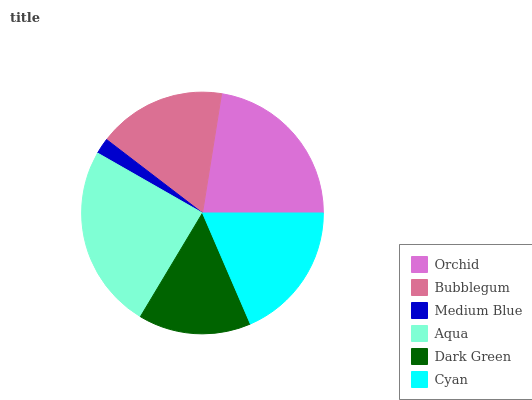Is Medium Blue the minimum?
Answer yes or no. Yes. Is Aqua the maximum?
Answer yes or no. Yes. Is Bubblegum the minimum?
Answer yes or no. No. Is Bubblegum the maximum?
Answer yes or no. No. Is Orchid greater than Bubblegum?
Answer yes or no. Yes. Is Bubblegum less than Orchid?
Answer yes or no. Yes. Is Bubblegum greater than Orchid?
Answer yes or no. No. Is Orchid less than Bubblegum?
Answer yes or no. No. Is Cyan the high median?
Answer yes or no. Yes. Is Bubblegum the low median?
Answer yes or no. Yes. Is Bubblegum the high median?
Answer yes or no. No. Is Medium Blue the low median?
Answer yes or no. No. 